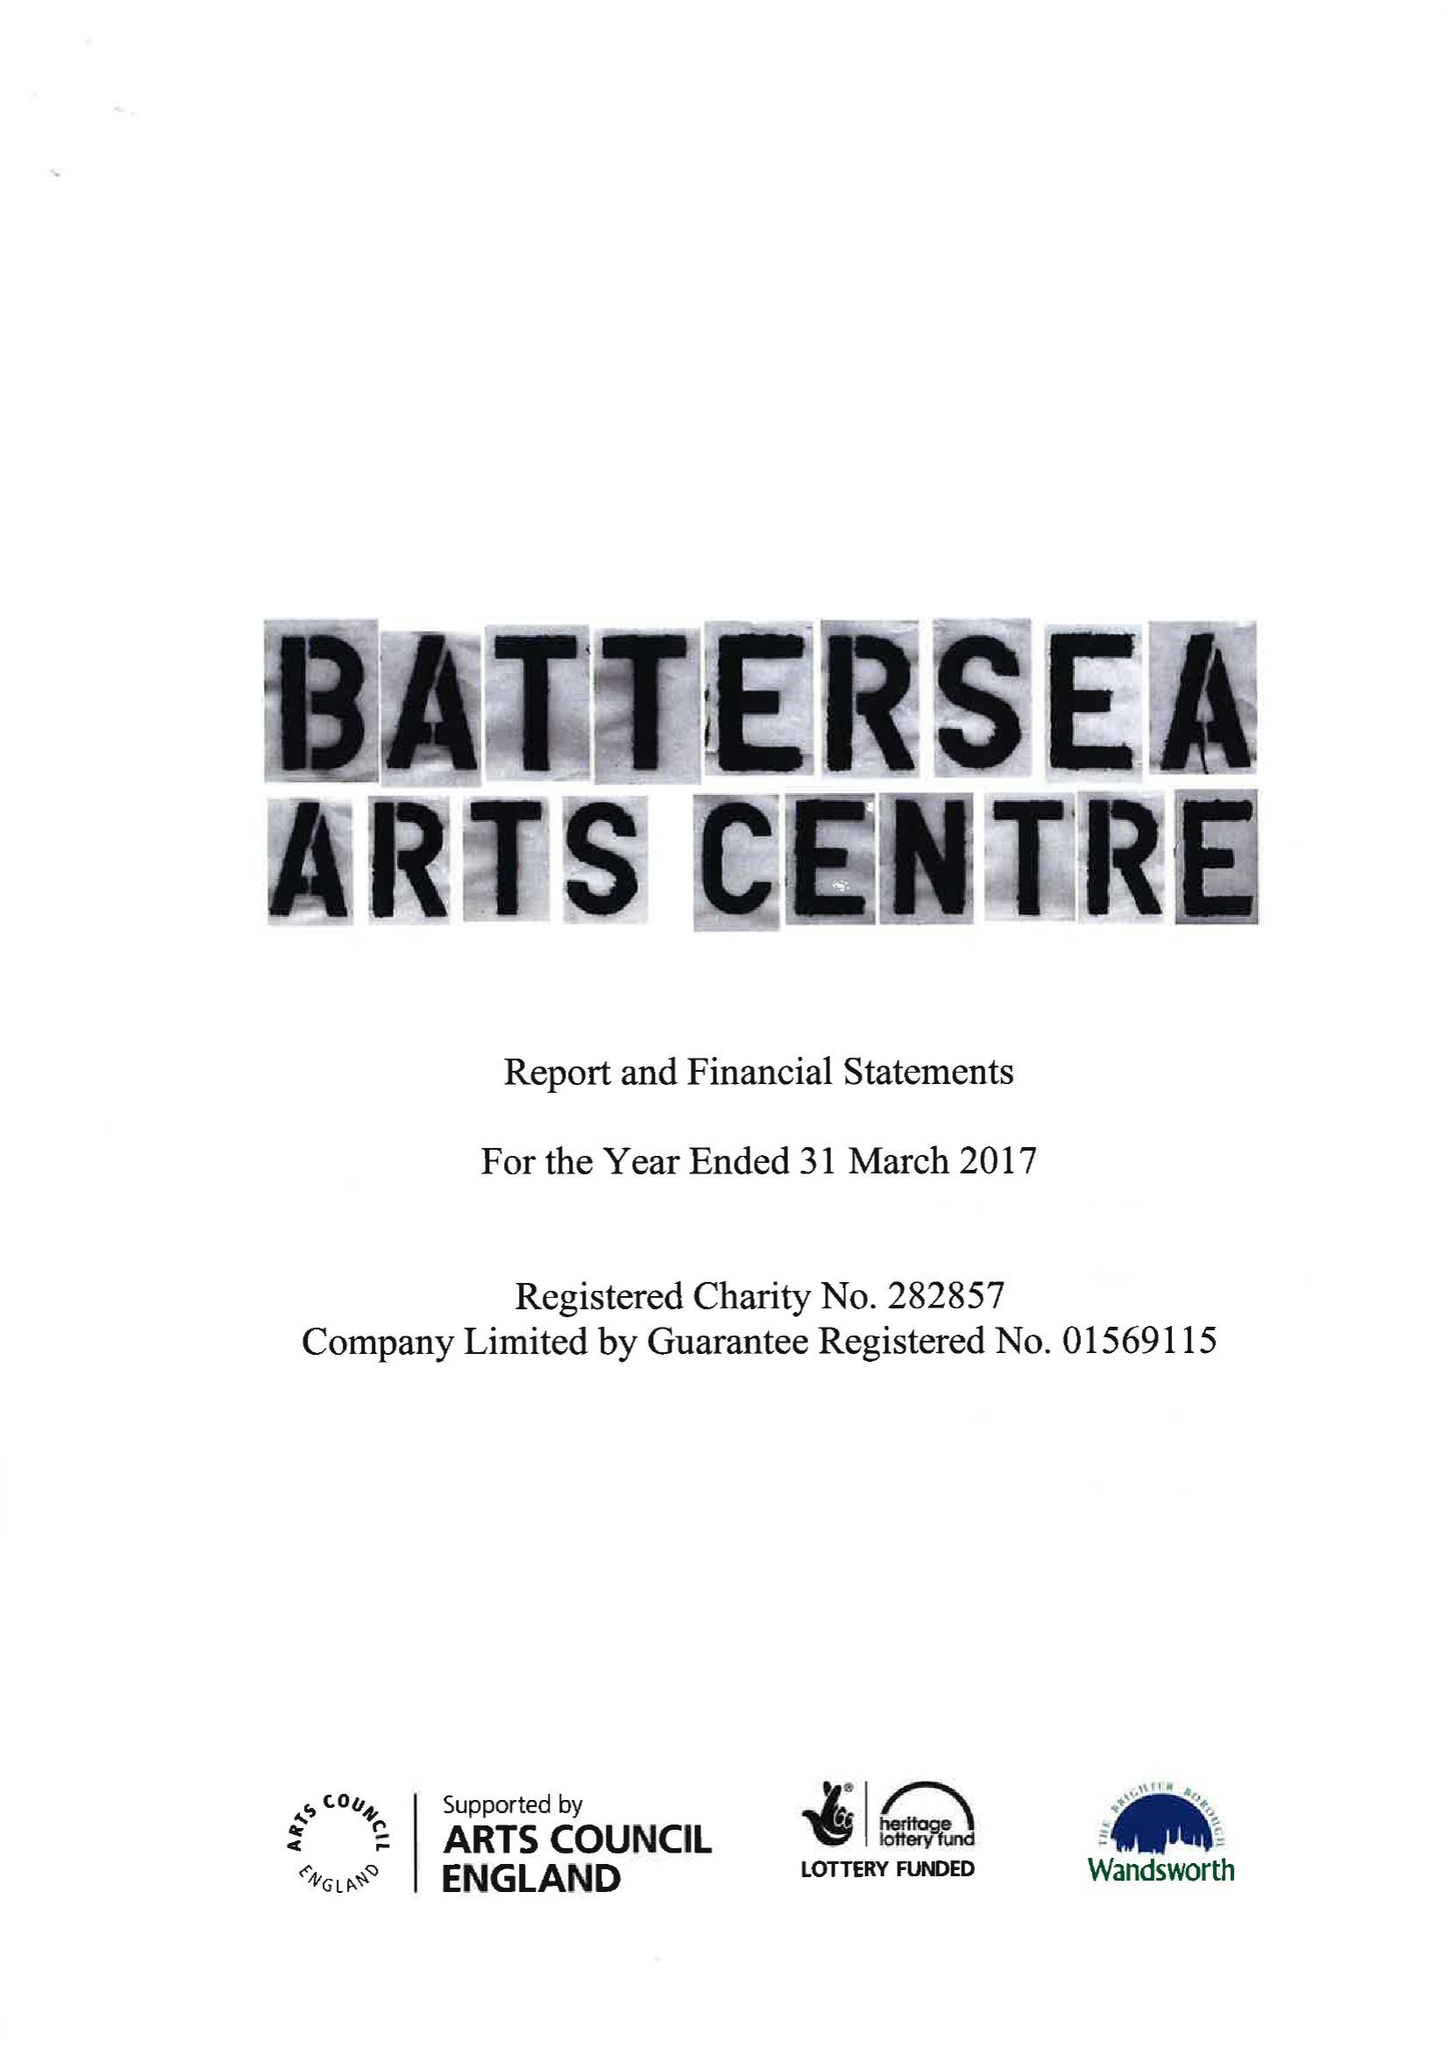What is the value for the address__street_line?
Answer the question using a single word or phrase. LAVENDER HILL 